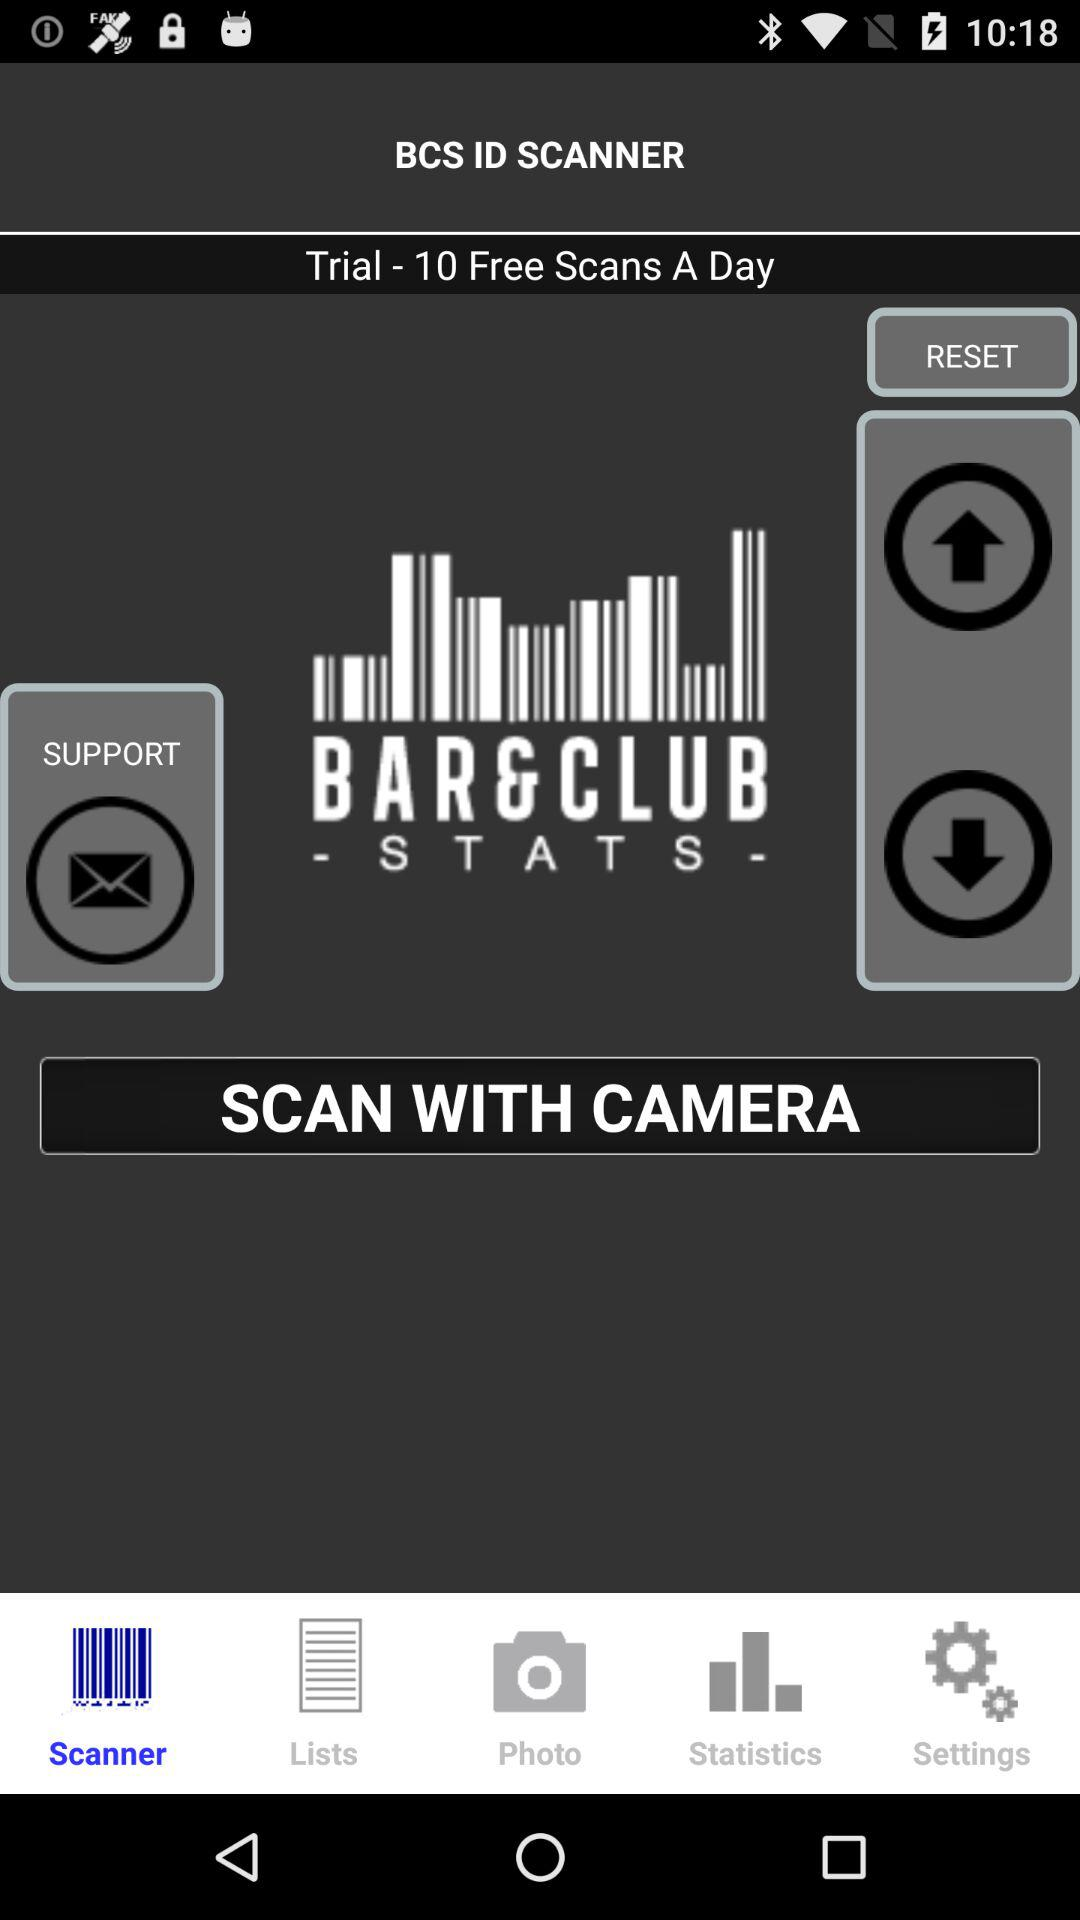What is the name of the application? The name of the application is "BCS ID SCANNER". 